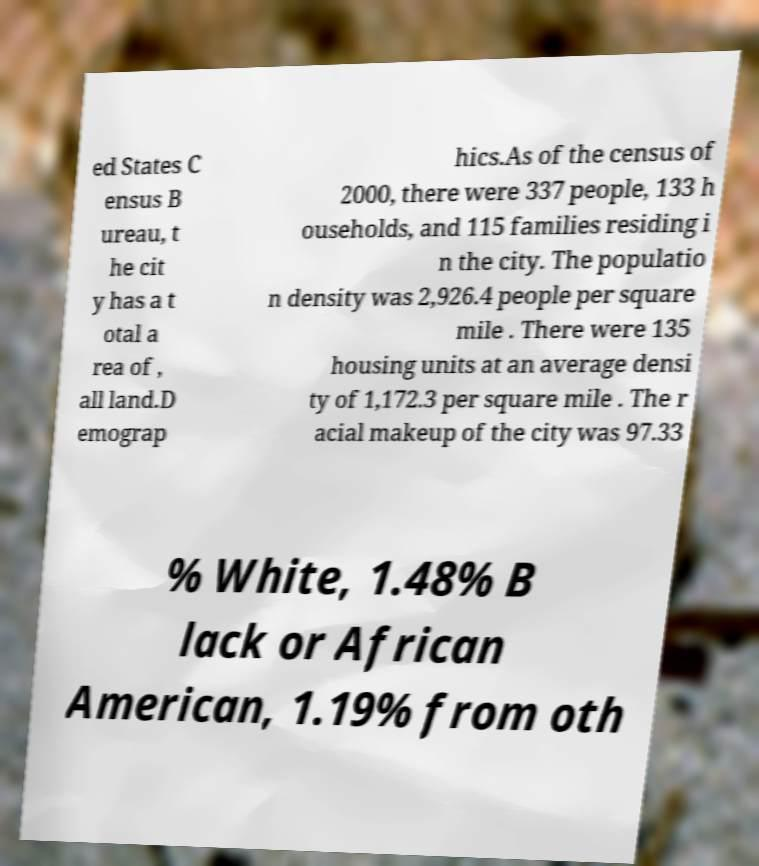For documentation purposes, I need the text within this image transcribed. Could you provide that? ed States C ensus B ureau, t he cit y has a t otal a rea of , all land.D emograp hics.As of the census of 2000, there were 337 people, 133 h ouseholds, and 115 families residing i n the city. The populatio n density was 2,926.4 people per square mile . There were 135 housing units at an average densi ty of 1,172.3 per square mile . The r acial makeup of the city was 97.33 % White, 1.48% B lack or African American, 1.19% from oth 